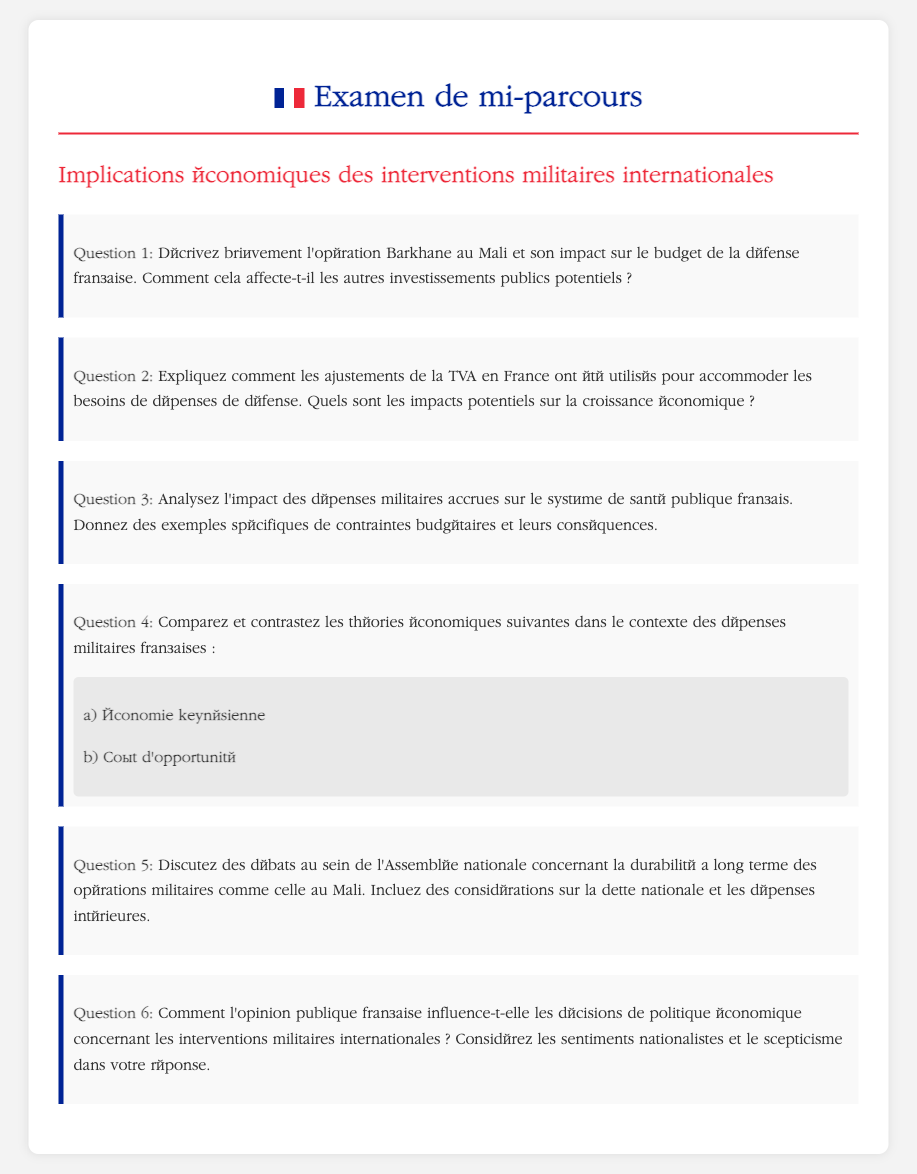Quelle est l'opération mentionnée au Mali ? L'opération mentionnée est Barkhane, qui est un effort militaire français.
Answer: Barkhane Quel est l'impact de l'opération Barkhane sur le budget de la défense ? Le document demande de décrire l'impact, ce qui implique une connaissance des influences financières.
Answer: Non spécifié Comment la TVA a-t-elle été ajustée en France ? La question se concentre sur les ajustements de la TVA pour les dépenses de défense, indiquant son application fiscale.
Answer: Non spécifié Quel système est analysé en relation avec les dépenses militaires ? La question mentionne le système de santé publique pour discuter des impacts budgétaires.
Answer: Système de santé publique Quels types de théories économiques sont comparés ? Les deux théories mentionnées sont l'économie keynésienne et le coût d'opportunité.
Answer: Économie keynésienne, Coût d'opportunité Quel est le sujet de débat au sein de l'Assemblée nationale ? Les débats concernent la durabilité à long terme des opérations militaires, reliant les dépenses à la dette nationale.
Answer: Durabilité des opérations militaires Comment l'opinion publique influence-t-elle les politiques ? Il est demandé de considérer les sentiments nationalistes et le scepticisme face aux interventions militaires.
Answer: Sentiments nationalistes et scepticisme 